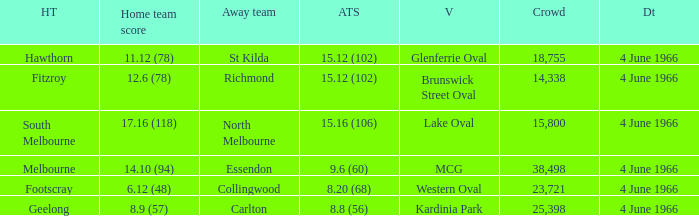What is the average crowd size of the away team who scored 9.6 (60)? 38498.0. 